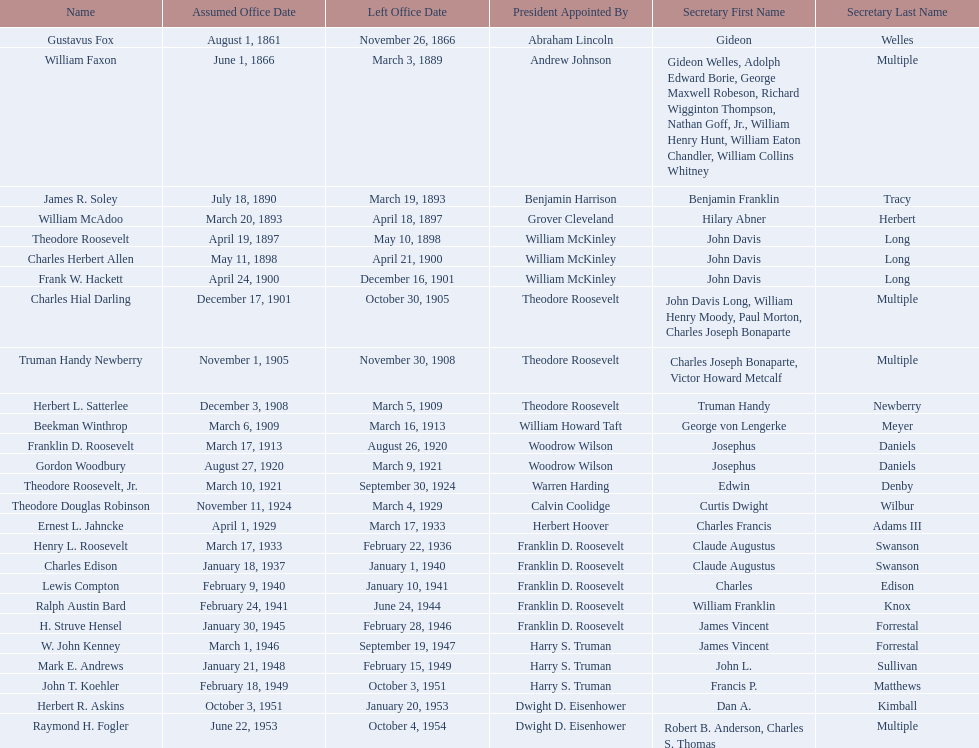Who are all of the assistant secretaries of the navy in the 20th century? Charles Herbert Allen, Frank W. Hackett, Charles Hial Darling, Truman Handy Newberry, Herbert L. Satterlee, Beekman Winthrop, Franklin D. Roosevelt, Gordon Woodbury, Theodore Roosevelt, Jr., Theodore Douglas Robinson, Ernest L. Jahncke, Henry L. Roosevelt, Charles Edison, Lewis Compton, Ralph Austin Bard, H. Struve Hensel, W. John Kenney, Mark E. Andrews, John T. Koehler, Herbert R. Askins, Raymond H. Fogler. What date was assistant secretary of the navy raymond h. fogler appointed? June 22, 1953. What date did assistant secretary of the navy raymond h. fogler leave office? October 4, 1954. 